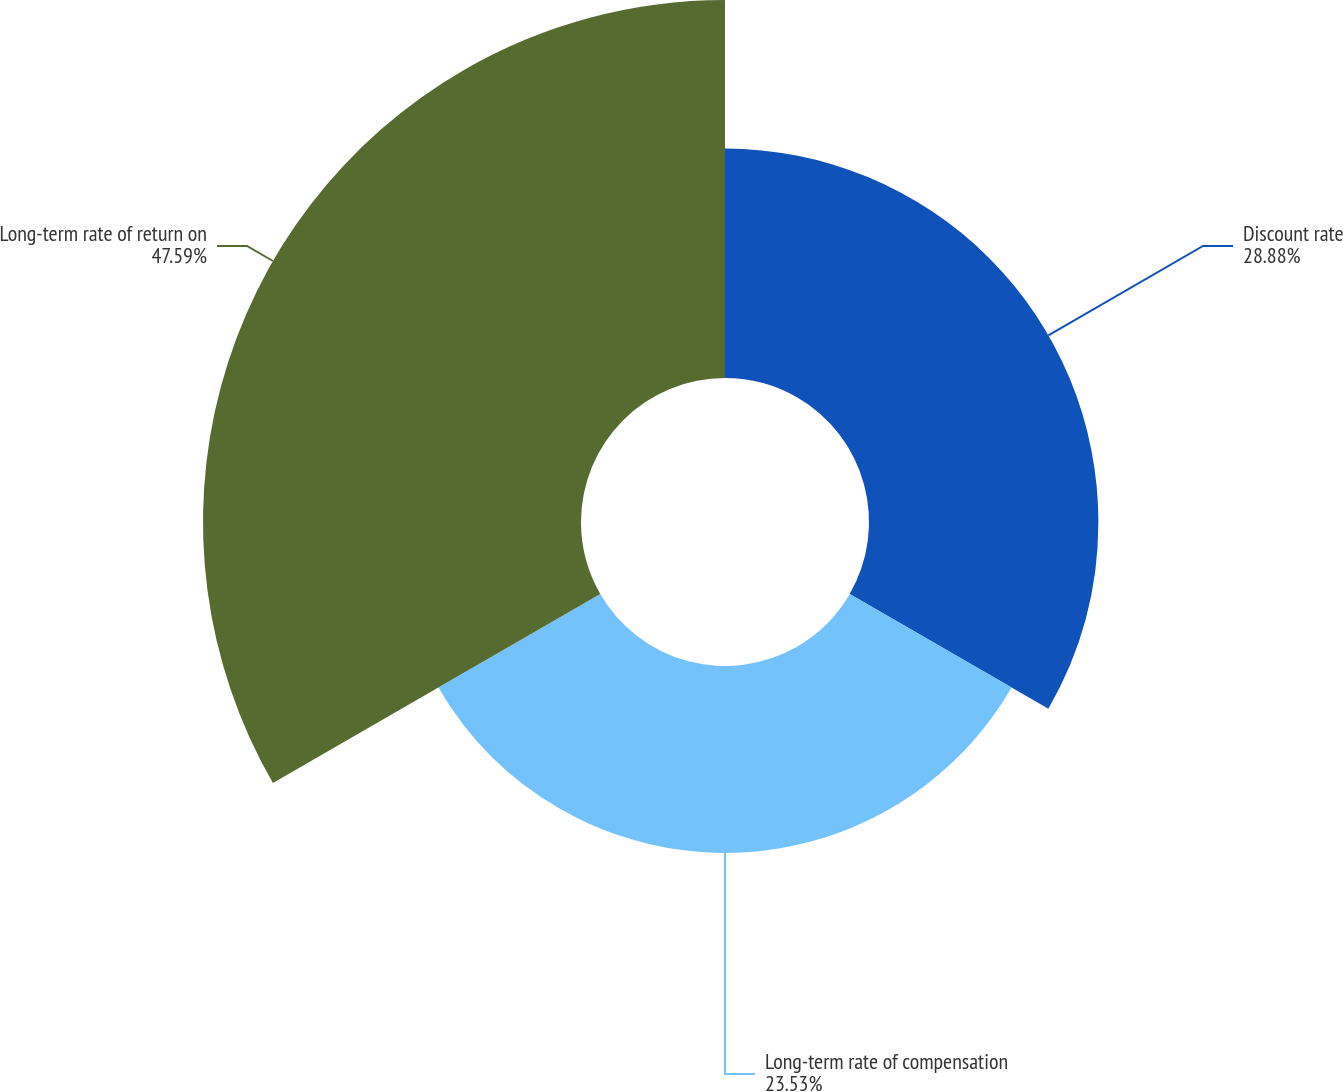<chart> <loc_0><loc_0><loc_500><loc_500><pie_chart><fcel>Discount rate<fcel>Long-term rate of compensation<fcel>Long-term rate of return on<nl><fcel>28.88%<fcel>23.53%<fcel>47.59%<nl></chart> 